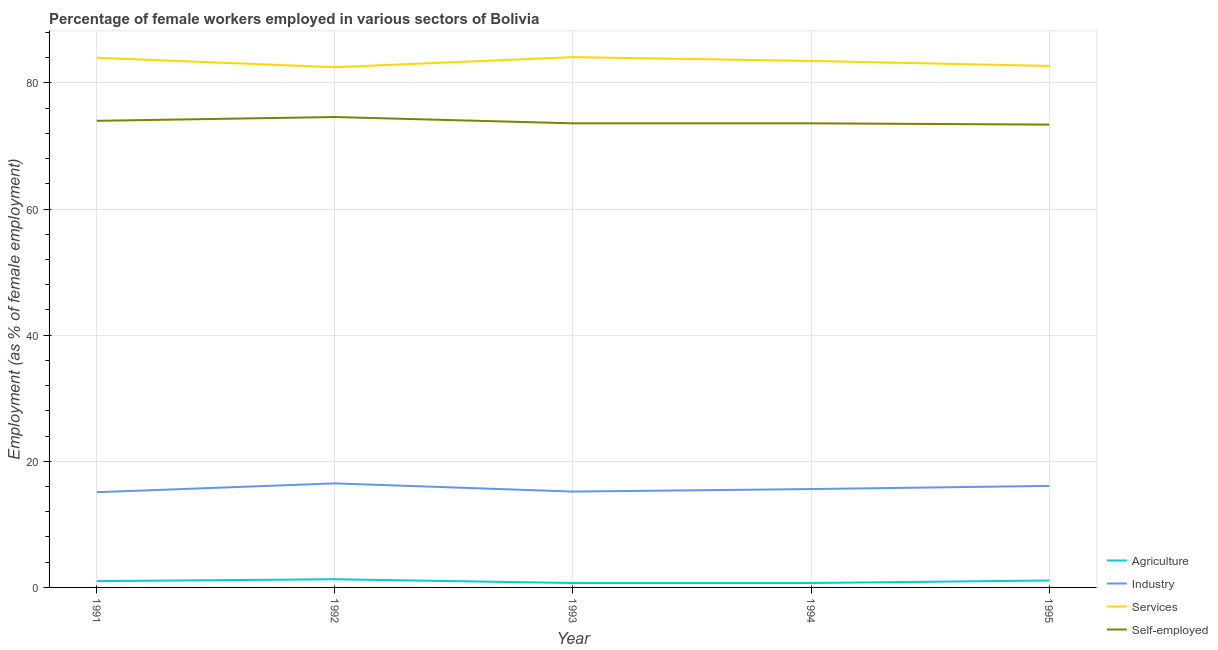Is the number of lines equal to the number of legend labels?
Your answer should be very brief. Yes. What is the percentage of female workers in industry in 1995?
Your response must be concise. 16.1. Across all years, what is the minimum percentage of female workers in industry?
Your response must be concise. 15.1. In which year was the percentage of female workers in industry maximum?
Your response must be concise. 1992. What is the total percentage of self employed female workers in the graph?
Offer a terse response. 369.2. What is the difference between the percentage of self employed female workers in 1992 and that in 1995?
Ensure brevity in your answer.  1.2. What is the difference between the percentage of female workers in agriculture in 1991 and the percentage of female workers in services in 1994?
Make the answer very short. -82.5. What is the average percentage of self employed female workers per year?
Offer a very short reply. 73.84. In the year 1992, what is the difference between the percentage of female workers in services and percentage of self employed female workers?
Provide a short and direct response. 7.9. In how many years, is the percentage of female workers in services greater than 72 %?
Make the answer very short. 5. What is the ratio of the percentage of female workers in industry in 1993 to that in 1994?
Ensure brevity in your answer.  0.97. Is the percentage of self employed female workers in 1991 less than that in 1993?
Your response must be concise. No. Is the difference between the percentage of female workers in industry in 1991 and 1994 greater than the difference between the percentage of female workers in services in 1991 and 1994?
Provide a short and direct response. No. What is the difference between the highest and the second highest percentage of female workers in industry?
Provide a short and direct response. 0.4. What is the difference between the highest and the lowest percentage of female workers in industry?
Offer a very short reply. 1.4. In how many years, is the percentage of female workers in agriculture greater than the average percentage of female workers in agriculture taken over all years?
Make the answer very short. 3. Does the percentage of self employed female workers monotonically increase over the years?
Your answer should be compact. No. Is the percentage of self employed female workers strictly greater than the percentage of female workers in services over the years?
Make the answer very short. No. How many years are there in the graph?
Provide a succinct answer. 5. Are the values on the major ticks of Y-axis written in scientific E-notation?
Make the answer very short. No. Does the graph contain grids?
Keep it short and to the point. Yes. Where does the legend appear in the graph?
Provide a short and direct response. Bottom right. How many legend labels are there?
Provide a succinct answer. 4. How are the legend labels stacked?
Provide a succinct answer. Vertical. What is the title of the graph?
Provide a short and direct response. Percentage of female workers employed in various sectors of Bolivia. Does "UNPBF" appear as one of the legend labels in the graph?
Provide a short and direct response. No. What is the label or title of the X-axis?
Ensure brevity in your answer.  Year. What is the label or title of the Y-axis?
Provide a short and direct response. Employment (as % of female employment). What is the Employment (as % of female employment) in Industry in 1991?
Your response must be concise. 15.1. What is the Employment (as % of female employment) of Services in 1991?
Your answer should be very brief. 84. What is the Employment (as % of female employment) in Agriculture in 1992?
Keep it short and to the point. 1.3. What is the Employment (as % of female employment) of Services in 1992?
Provide a succinct answer. 82.5. What is the Employment (as % of female employment) in Self-employed in 1992?
Give a very brief answer. 74.6. What is the Employment (as % of female employment) in Agriculture in 1993?
Make the answer very short. 0.7. What is the Employment (as % of female employment) in Industry in 1993?
Offer a terse response. 15.2. What is the Employment (as % of female employment) in Services in 1993?
Your answer should be very brief. 84.1. What is the Employment (as % of female employment) in Self-employed in 1993?
Provide a succinct answer. 73.6. What is the Employment (as % of female employment) of Agriculture in 1994?
Give a very brief answer. 0.7. What is the Employment (as % of female employment) of Industry in 1994?
Offer a very short reply. 15.6. What is the Employment (as % of female employment) in Services in 1994?
Keep it short and to the point. 83.5. What is the Employment (as % of female employment) in Self-employed in 1994?
Offer a very short reply. 73.6. What is the Employment (as % of female employment) in Agriculture in 1995?
Provide a short and direct response. 1.1. What is the Employment (as % of female employment) of Industry in 1995?
Ensure brevity in your answer.  16.1. What is the Employment (as % of female employment) in Services in 1995?
Provide a short and direct response. 82.7. What is the Employment (as % of female employment) of Self-employed in 1995?
Give a very brief answer. 73.4. Across all years, what is the maximum Employment (as % of female employment) in Agriculture?
Offer a very short reply. 1.3. Across all years, what is the maximum Employment (as % of female employment) in Services?
Give a very brief answer. 84.1. Across all years, what is the maximum Employment (as % of female employment) of Self-employed?
Provide a succinct answer. 74.6. Across all years, what is the minimum Employment (as % of female employment) of Agriculture?
Give a very brief answer. 0.7. Across all years, what is the minimum Employment (as % of female employment) of Industry?
Your answer should be very brief. 15.1. Across all years, what is the minimum Employment (as % of female employment) of Services?
Ensure brevity in your answer.  82.5. Across all years, what is the minimum Employment (as % of female employment) of Self-employed?
Keep it short and to the point. 73.4. What is the total Employment (as % of female employment) of Industry in the graph?
Make the answer very short. 78.5. What is the total Employment (as % of female employment) in Services in the graph?
Offer a terse response. 416.8. What is the total Employment (as % of female employment) of Self-employed in the graph?
Your answer should be very brief. 369.2. What is the difference between the Employment (as % of female employment) of Agriculture in 1991 and that in 1992?
Give a very brief answer. -0.3. What is the difference between the Employment (as % of female employment) of Industry in 1991 and that in 1992?
Provide a succinct answer. -1.4. What is the difference between the Employment (as % of female employment) in Services in 1991 and that in 1992?
Keep it short and to the point. 1.5. What is the difference between the Employment (as % of female employment) of Self-employed in 1991 and that in 1992?
Offer a terse response. -0.6. What is the difference between the Employment (as % of female employment) in Industry in 1991 and that in 1993?
Make the answer very short. -0.1. What is the difference between the Employment (as % of female employment) of Industry in 1991 and that in 1994?
Make the answer very short. -0.5. What is the difference between the Employment (as % of female employment) of Self-employed in 1991 and that in 1994?
Keep it short and to the point. 0.4. What is the difference between the Employment (as % of female employment) in Self-employed in 1991 and that in 1995?
Your answer should be compact. 0.6. What is the difference between the Employment (as % of female employment) of Industry in 1992 and that in 1993?
Offer a very short reply. 1.3. What is the difference between the Employment (as % of female employment) of Services in 1992 and that in 1993?
Keep it short and to the point. -1.6. What is the difference between the Employment (as % of female employment) in Self-employed in 1992 and that in 1993?
Your answer should be compact. 1. What is the difference between the Employment (as % of female employment) of Agriculture in 1992 and that in 1994?
Provide a succinct answer. 0.6. What is the difference between the Employment (as % of female employment) in Industry in 1992 and that in 1994?
Give a very brief answer. 0.9. What is the difference between the Employment (as % of female employment) of Self-employed in 1992 and that in 1994?
Your answer should be very brief. 1. What is the difference between the Employment (as % of female employment) of Agriculture in 1992 and that in 1995?
Make the answer very short. 0.2. What is the difference between the Employment (as % of female employment) of Services in 1992 and that in 1995?
Make the answer very short. -0.2. What is the difference between the Employment (as % of female employment) in Self-employed in 1992 and that in 1995?
Provide a short and direct response. 1.2. What is the difference between the Employment (as % of female employment) in Industry in 1993 and that in 1994?
Make the answer very short. -0.4. What is the difference between the Employment (as % of female employment) in Agriculture in 1993 and that in 1995?
Keep it short and to the point. -0.4. What is the difference between the Employment (as % of female employment) in Self-employed in 1993 and that in 1995?
Your answer should be compact. 0.2. What is the difference between the Employment (as % of female employment) of Agriculture in 1994 and that in 1995?
Keep it short and to the point. -0.4. What is the difference between the Employment (as % of female employment) in Industry in 1994 and that in 1995?
Your response must be concise. -0.5. What is the difference between the Employment (as % of female employment) of Services in 1994 and that in 1995?
Offer a terse response. 0.8. What is the difference between the Employment (as % of female employment) of Agriculture in 1991 and the Employment (as % of female employment) of Industry in 1992?
Offer a terse response. -15.5. What is the difference between the Employment (as % of female employment) in Agriculture in 1991 and the Employment (as % of female employment) in Services in 1992?
Give a very brief answer. -81.5. What is the difference between the Employment (as % of female employment) of Agriculture in 1991 and the Employment (as % of female employment) of Self-employed in 1992?
Provide a succinct answer. -73.6. What is the difference between the Employment (as % of female employment) in Industry in 1991 and the Employment (as % of female employment) in Services in 1992?
Your answer should be very brief. -67.4. What is the difference between the Employment (as % of female employment) of Industry in 1991 and the Employment (as % of female employment) of Self-employed in 1992?
Your answer should be very brief. -59.5. What is the difference between the Employment (as % of female employment) in Agriculture in 1991 and the Employment (as % of female employment) in Services in 1993?
Provide a succinct answer. -83.1. What is the difference between the Employment (as % of female employment) in Agriculture in 1991 and the Employment (as % of female employment) in Self-employed in 1993?
Your answer should be very brief. -72.6. What is the difference between the Employment (as % of female employment) of Industry in 1991 and the Employment (as % of female employment) of Services in 1993?
Keep it short and to the point. -69. What is the difference between the Employment (as % of female employment) of Industry in 1991 and the Employment (as % of female employment) of Self-employed in 1993?
Provide a succinct answer. -58.5. What is the difference between the Employment (as % of female employment) in Agriculture in 1991 and the Employment (as % of female employment) in Industry in 1994?
Keep it short and to the point. -14.6. What is the difference between the Employment (as % of female employment) of Agriculture in 1991 and the Employment (as % of female employment) of Services in 1994?
Keep it short and to the point. -82.5. What is the difference between the Employment (as % of female employment) in Agriculture in 1991 and the Employment (as % of female employment) in Self-employed in 1994?
Your answer should be very brief. -72.6. What is the difference between the Employment (as % of female employment) of Industry in 1991 and the Employment (as % of female employment) of Services in 1994?
Provide a short and direct response. -68.4. What is the difference between the Employment (as % of female employment) in Industry in 1991 and the Employment (as % of female employment) in Self-employed in 1994?
Your answer should be compact. -58.5. What is the difference between the Employment (as % of female employment) in Agriculture in 1991 and the Employment (as % of female employment) in Industry in 1995?
Your response must be concise. -15.1. What is the difference between the Employment (as % of female employment) in Agriculture in 1991 and the Employment (as % of female employment) in Services in 1995?
Ensure brevity in your answer.  -81.7. What is the difference between the Employment (as % of female employment) in Agriculture in 1991 and the Employment (as % of female employment) in Self-employed in 1995?
Your answer should be compact. -72.4. What is the difference between the Employment (as % of female employment) of Industry in 1991 and the Employment (as % of female employment) of Services in 1995?
Offer a terse response. -67.6. What is the difference between the Employment (as % of female employment) in Industry in 1991 and the Employment (as % of female employment) in Self-employed in 1995?
Make the answer very short. -58.3. What is the difference between the Employment (as % of female employment) in Agriculture in 1992 and the Employment (as % of female employment) in Services in 1993?
Your answer should be compact. -82.8. What is the difference between the Employment (as % of female employment) in Agriculture in 1992 and the Employment (as % of female employment) in Self-employed in 1993?
Ensure brevity in your answer.  -72.3. What is the difference between the Employment (as % of female employment) in Industry in 1992 and the Employment (as % of female employment) in Services in 1993?
Make the answer very short. -67.6. What is the difference between the Employment (as % of female employment) in Industry in 1992 and the Employment (as % of female employment) in Self-employed in 1993?
Your answer should be compact. -57.1. What is the difference between the Employment (as % of female employment) of Services in 1992 and the Employment (as % of female employment) of Self-employed in 1993?
Your response must be concise. 8.9. What is the difference between the Employment (as % of female employment) in Agriculture in 1992 and the Employment (as % of female employment) in Industry in 1994?
Provide a short and direct response. -14.3. What is the difference between the Employment (as % of female employment) of Agriculture in 1992 and the Employment (as % of female employment) of Services in 1994?
Make the answer very short. -82.2. What is the difference between the Employment (as % of female employment) in Agriculture in 1992 and the Employment (as % of female employment) in Self-employed in 1994?
Provide a short and direct response. -72.3. What is the difference between the Employment (as % of female employment) in Industry in 1992 and the Employment (as % of female employment) in Services in 1994?
Offer a very short reply. -67. What is the difference between the Employment (as % of female employment) of Industry in 1992 and the Employment (as % of female employment) of Self-employed in 1994?
Provide a succinct answer. -57.1. What is the difference between the Employment (as % of female employment) of Agriculture in 1992 and the Employment (as % of female employment) of Industry in 1995?
Ensure brevity in your answer.  -14.8. What is the difference between the Employment (as % of female employment) in Agriculture in 1992 and the Employment (as % of female employment) in Services in 1995?
Ensure brevity in your answer.  -81.4. What is the difference between the Employment (as % of female employment) of Agriculture in 1992 and the Employment (as % of female employment) of Self-employed in 1995?
Your response must be concise. -72.1. What is the difference between the Employment (as % of female employment) of Industry in 1992 and the Employment (as % of female employment) of Services in 1995?
Keep it short and to the point. -66.2. What is the difference between the Employment (as % of female employment) in Industry in 1992 and the Employment (as % of female employment) in Self-employed in 1995?
Ensure brevity in your answer.  -56.9. What is the difference between the Employment (as % of female employment) of Agriculture in 1993 and the Employment (as % of female employment) of Industry in 1994?
Make the answer very short. -14.9. What is the difference between the Employment (as % of female employment) in Agriculture in 1993 and the Employment (as % of female employment) in Services in 1994?
Ensure brevity in your answer.  -82.8. What is the difference between the Employment (as % of female employment) in Agriculture in 1993 and the Employment (as % of female employment) in Self-employed in 1994?
Your response must be concise. -72.9. What is the difference between the Employment (as % of female employment) in Industry in 1993 and the Employment (as % of female employment) in Services in 1994?
Ensure brevity in your answer.  -68.3. What is the difference between the Employment (as % of female employment) of Industry in 1993 and the Employment (as % of female employment) of Self-employed in 1994?
Provide a succinct answer. -58.4. What is the difference between the Employment (as % of female employment) of Agriculture in 1993 and the Employment (as % of female employment) of Industry in 1995?
Provide a short and direct response. -15.4. What is the difference between the Employment (as % of female employment) in Agriculture in 1993 and the Employment (as % of female employment) in Services in 1995?
Offer a terse response. -82. What is the difference between the Employment (as % of female employment) in Agriculture in 1993 and the Employment (as % of female employment) in Self-employed in 1995?
Your answer should be compact. -72.7. What is the difference between the Employment (as % of female employment) in Industry in 1993 and the Employment (as % of female employment) in Services in 1995?
Offer a terse response. -67.5. What is the difference between the Employment (as % of female employment) in Industry in 1993 and the Employment (as % of female employment) in Self-employed in 1995?
Ensure brevity in your answer.  -58.2. What is the difference between the Employment (as % of female employment) of Agriculture in 1994 and the Employment (as % of female employment) of Industry in 1995?
Your answer should be compact. -15.4. What is the difference between the Employment (as % of female employment) in Agriculture in 1994 and the Employment (as % of female employment) in Services in 1995?
Your answer should be very brief. -82. What is the difference between the Employment (as % of female employment) in Agriculture in 1994 and the Employment (as % of female employment) in Self-employed in 1995?
Offer a very short reply. -72.7. What is the difference between the Employment (as % of female employment) in Industry in 1994 and the Employment (as % of female employment) in Services in 1995?
Provide a succinct answer. -67.1. What is the difference between the Employment (as % of female employment) of Industry in 1994 and the Employment (as % of female employment) of Self-employed in 1995?
Your response must be concise. -57.8. What is the average Employment (as % of female employment) in Agriculture per year?
Provide a succinct answer. 0.96. What is the average Employment (as % of female employment) in Industry per year?
Keep it short and to the point. 15.7. What is the average Employment (as % of female employment) of Services per year?
Keep it short and to the point. 83.36. What is the average Employment (as % of female employment) of Self-employed per year?
Your response must be concise. 73.84. In the year 1991, what is the difference between the Employment (as % of female employment) of Agriculture and Employment (as % of female employment) of Industry?
Your response must be concise. -14.1. In the year 1991, what is the difference between the Employment (as % of female employment) of Agriculture and Employment (as % of female employment) of Services?
Offer a terse response. -83. In the year 1991, what is the difference between the Employment (as % of female employment) in Agriculture and Employment (as % of female employment) in Self-employed?
Ensure brevity in your answer.  -73. In the year 1991, what is the difference between the Employment (as % of female employment) in Industry and Employment (as % of female employment) in Services?
Your answer should be compact. -68.9. In the year 1991, what is the difference between the Employment (as % of female employment) of Industry and Employment (as % of female employment) of Self-employed?
Offer a very short reply. -58.9. In the year 1992, what is the difference between the Employment (as % of female employment) of Agriculture and Employment (as % of female employment) of Industry?
Provide a succinct answer. -15.2. In the year 1992, what is the difference between the Employment (as % of female employment) of Agriculture and Employment (as % of female employment) of Services?
Make the answer very short. -81.2. In the year 1992, what is the difference between the Employment (as % of female employment) in Agriculture and Employment (as % of female employment) in Self-employed?
Your response must be concise. -73.3. In the year 1992, what is the difference between the Employment (as % of female employment) of Industry and Employment (as % of female employment) of Services?
Offer a terse response. -66. In the year 1992, what is the difference between the Employment (as % of female employment) in Industry and Employment (as % of female employment) in Self-employed?
Give a very brief answer. -58.1. In the year 1992, what is the difference between the Employment (as % of female employment) in Services and Employment (as % of female employment) in Self-employed?
Provide a short and direct response. 7.9. In the year 1993, what is the difference between the Employment (as % of female employment) in Agriculture and Employment (as % of female employment) in Services?
Your response must be concise. -83.4. In the year 1993, what is the difference between the Employment (as % of female employment) of Agriculture and Employment (as % of female employment) of Self-employed?
Provide a short and direct response. -72.9. In the year 1993, what is the difference between the Employment (as % of female employment) of Industry and Employment (as % of female employment) of Services?
Make the answer very short. -68.9. In the year 1993, what is the difference between the Employment (as % of female employment) of Industry and Employment (as % of female employment) of Self-employed?
Offer a very short reply. -58.4. In the year 1993, what is the difference between the Employment (as % of female employment) of Services and Employment (as % of female employment) of Self-employed?
Provide a succinct answer. 10.5. In the year 1994, what is the difference between the Employment (as % of female employment) in Agriculture and Employment (as % of female employment) in Industry?
Your response must be concise. -14.9. In the year 1994, what is the difference between the Employment (as % of female employment) of Agriculture and Employment (as % of female employment) of Services?
Offer a very short reply. -82.8. In the year 1994, what is the difference between the Employment (as % of female employment) in Agriculture and Employment (as % of female employment) in Self-employed?
Keep it short and to the point. -72.9. In the year 1994, what is the difference between the Employment (as % of female employment) in Industry and Employment (as % of female employment) in Services?
Your answer should be compact. -67.9. In the year 1994, what is the difference between the Employment (as % of female employment) in Industry and Employment (as % of female employment) in Self-employed?
Provide a succinct answer. -58. In the year 1994, what is the difference between the Employment (as % of female employment) in Services and Employment (as % of female employment) in Self-employed?
Offer a terse response. 9.9. In the year 1995, what is the difference between the Employment (as % of female employment) of Agriculture and Employment (as % of female employment) of Services?
Offer a terse response. -81.6. In the year 1995, what is the difference between the Employment (as % of female employment) in Agriculture and Employment (as % of female employment) in Self-employed?
Provide a succinct answer. -72.3. In the year 1995, what is the difference between the Employment (as % of female employment) of Industry and Employment (as % of female employment) of Services?
Provide a short and direct response. -66.6. In the year 1995, what is the difference between the Employment (as % of female employment) of Industry and Employment (as % of female employment) of Self-employed?
Your answer should be very brief. -57.3. What is the ratio of the Employment (as % of female employment) in Agriculture in 1991 to that in 1992?
Your response must be concise. 0.77. What is the ratio of the Employment (as % of female employment) in Industry in 1991 to that in 1992?
Offer a very short reply. 0.92. What is the ratio of the Employment (as % of female employment) of Services in 1991 to that in 1992?
Give a very brief answer. 1.02. What is the ratio of the Employment (as % of female employment) of Agriculture in 1991 to that in 1993?
Ensure brevity in your answer.  1.43. What is the ratio of the Employment (as % of female employment) in Industry in 1991 to that in 1993?
Give a very brief answer. 0.99. What is the ratio of the Employment (as % of female employment) of Self-employed in 1991 to that in 1993?
Ensure brevity in your answer.  1.01. What is the ratio of the Employment (as % of female employment) in Agriculture in 1991 to that in 1994?
Ensure brevity in your answer.  1.43. What is the ratio of the Employment (as % of female employment) in Industry in 1991 to that in 1994?
Your answer should be compact. 0.97. What is the ratio of the Employment (as % of female employment) of Services in 1991 to that in 1994?
Your response must be concise. 1.01. What is the ratio of the Employment (as % of female employment) of Self-employed in 1991 to that in 1994?
Make the answer very short. 1.01. What is the ratio of the Employment (as % of female employment) of Agriculture in 1991 to that in 1995?
Give a very brief answer. 0.91. What is the ratio of the Employment (as % of female employment) in Industry in 1991 to that in 1995?
Ensure brevity in your answer.  0.94. What is the ratio of the Employment (as % of female employment) of Services in 1991 to that in 1995?
Offer a terse response. 1.02. What is the ratio of the Employment (as % of female employment) of Self-employed in 1991 to that in 1995?
Give a very brief answer. 1.01. What is the ratio of the Employment (as % of female employment) in Agriculture in 1992 to that in 1993?
Offer a terse response. 1.86. What is the ratio of the Employment (as % of female employment) of Industry in 1992 to that in 1993?
Your response must be concise. 1.09. What is the ratio of the Employment (as % of female employment) of Services in 1992 to that in 1993?
Your answer should be very brief. 0.98. What is the ratio of the Employment (as % of female employment) of Self-employed in 1992 to that in 1993?
Give a very brief answer. 1.01. What is the ratio of the Employment (as % of female employment) in Agriculture in 1992 to that in 1994?
Make the answer very short. 1.86. What is the ratio of the Employment (as % of female employment) in Industry in 1992 to that in 1994?
Offer a very short reply. 1.06. What is the ratio of the Employment (as % of female employment) in Services in 1992 to that in 1994?
Your response must be concise. 0.99. What is the ratio of the Employment (as % of female employment) of Self-employed in 1992 to that in 1994?
Offer a very short reply. 1.01. What is the ratio of the Employment (as % of female employment) of Agriculture in 1992 to that in 1995?
Your answer should be very brief. 1.18. What is the ratio of the Employment (as % of female employment) of Industry in 1992 to that in 1995?
Keep it short and to the point. 1.02. What is the ratio of the Employment (as % of female employment) in Services in 1992 to that in 1995?
Your answer should be very brief. 1. What is the ratio of the Employment (as % of female employment) in Self-employed in 1992 to that in 1995?
Ensure brevity in your answer.  1.02. What is the ratio of the Employment (as % of female employment) of Industry in 1993 to that in 1994?
Offer a very short reply. 0.97. What is the ratio of the Employment (as % of female employment) of Self-employed in 1993 to that in 1994?
Offer a very short reply. 1. What is the ratio of the Employment (as % of female employment) in Agriculture in 1993 to that in 1995?
Offer a very short reply. 0.64. What is the ratio of the Employment (as % of female employment) of Industry in 1993 to that in 1995?
Offer a terse response. 0.94. What is the ratio of the Employment (as % of female employment) in Services in 1993 to that in 1995?
Your answer should be very brief. 1.02. What is the ratio of the Employment (as % of female employment) in Self-employed in 1993 to that in 1995?
Offer a terse response. 1. What is the ratio of the Employment (as % of female employment) of Agriculture in 1994 to that in 1995?
Provide a short and direct response. 0.64. What is the ratio of the Employment (as % of female employment) of Industry in 1994 to that in 1995?
Provide a short and direct response. 0.97. What is the ratio of the Employment (as % of female employment) of Services in 1994 to that in 1995?
Provide a short and direct response. 1.01. What is the difference between the highest and the second highest Employment (as % of female employment) in Industry?
Offer a terse response. 0.4. What is the difference between the highest and the second highest Employment (as % of female employment) of Services?
Offer a very short reply. 0.1. What is the difference between the highest and the second highest Employment (as % of female employment) of Self-employed?
Give a very brief answer. 0.6. What is the difference between the highest and the lowest Employment (as % of female employment) in Agriculture?
Offer a very short reply. 0.6. 